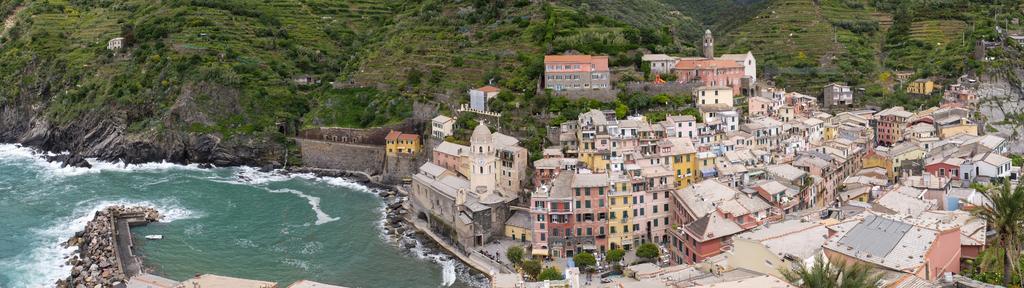How would you summarize this image in a sentence or two? In this image there are houses, the sea, a mountain, on that mountain there are trees. 